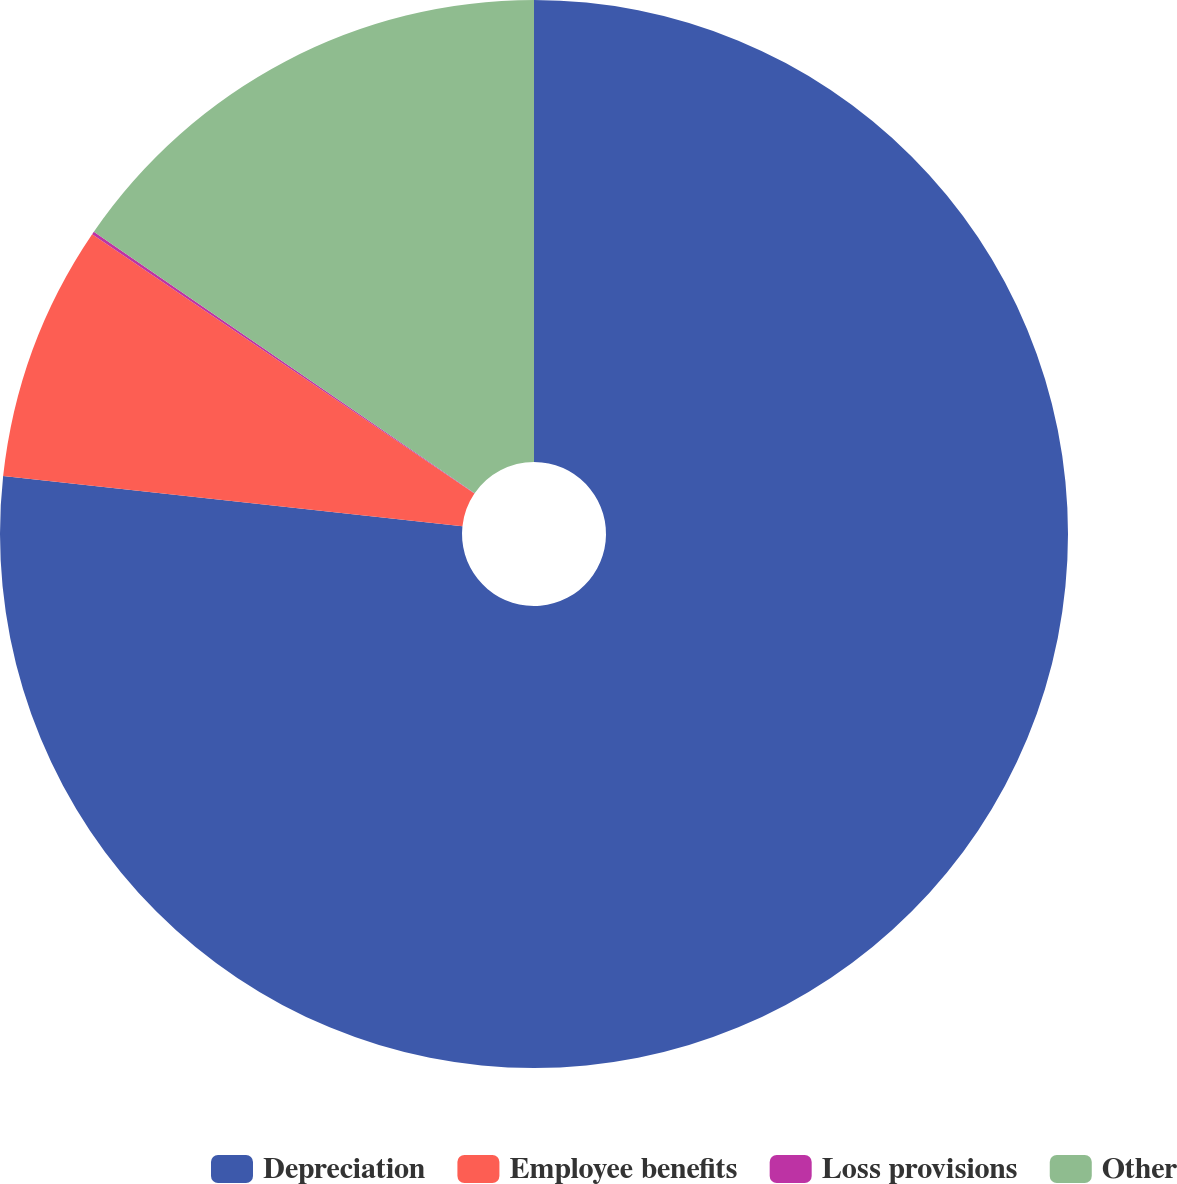<chart> <loc_0><loc_0><loc_500><loc_500><pie_chart><fcel>Depreciation<fcel>Employee benefits<fcel>Loss provisions<fcel>Other<nl><fcel>76.73%<fcel>7.76%<fcel>0.09%<fcel>15.42%<nl></chart> 